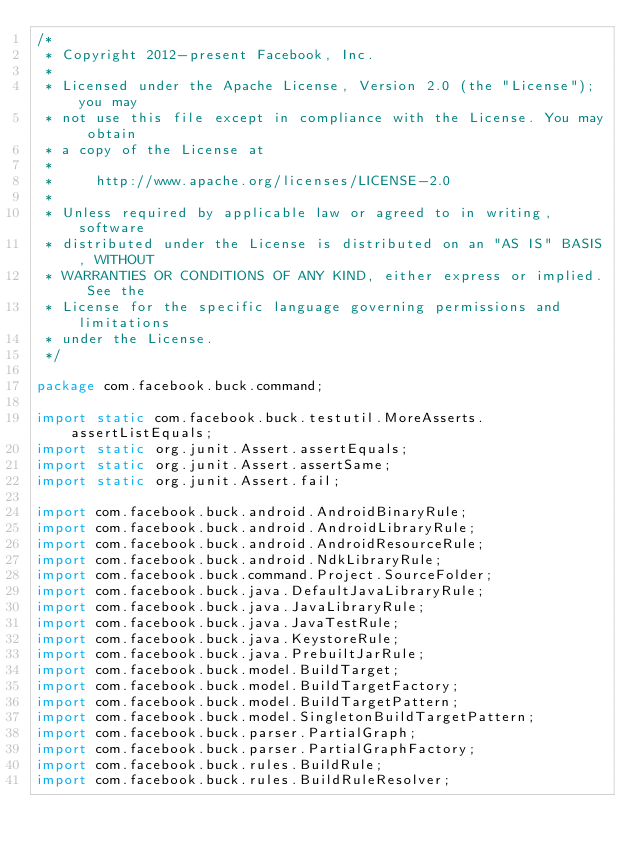<code> <loc_0><loc_0><loc_500><loc_500><_Java_>/*
 * Copyright 2012-present Facebook, Inc.
 *
 * Licensed under the Apache License, Version 2.0 (the "License"); you may
 * not use this file except in compliance with the License. You may obtain
 * a copy of the License at
 *
 *     http://www.apache.org/licenses/LICENSE-2.0
 *
 * Unless required by applicable law or agreed to in writing, software
 * distributed under the License is distributed on an "AS IS" BASIS, WITHOUT
 * WARRANTIES OR CONDITIONS OF ANY KIND, either express or implied. See the
 * License for the specific language governing permissions and limitations
 * under the License.
 */

package com.facebook.buck.command;

import static com.facebook.buck.testutil.MoreAsserts.assertListEquals;
import static org.junit.Assert.assertEquals;
import static org.junit.Assert.assertSame;
import static org.junit.Assert.fail;

import com.facebook.buck.android.AndroidBinaryRule;
import com.facebook.buck.android.AndroidLibraryRule;
import com.facebook.buck.android.AndroidResourceRule;
import com.facebook.buck.android.NdkLibraryRule;
import com.facebook.buck.command.Project.SourceFolder;
import com.facebook.buck.java.DefaultJavaLibraryRule;
import com.facebook.buck.java.JavaLibraryRule;
import com.facebook.buck.java.JavaTestRule;
import com.facebook.buck.java.KeystoreRule;
import com.facebook.buck.java.PrebuiltJarRule;
import com.facebook.buck.model.BuildTarget;
import com.facebook.buck.model.BuildTargetFactory;
import com.facebook.buck.model.BuildTargetPattern;
import com.facebook.buck.model.SingletonBuildTargetPattern;
import com.facebook.buck.parser.PartialGraph;
import com.facebook.buck.parser.PartialGraphFactory;
import com.facebook.buck.rules.BuildRule;
import com.facebook.buck.rules.BuildRuleResolver;</code> 